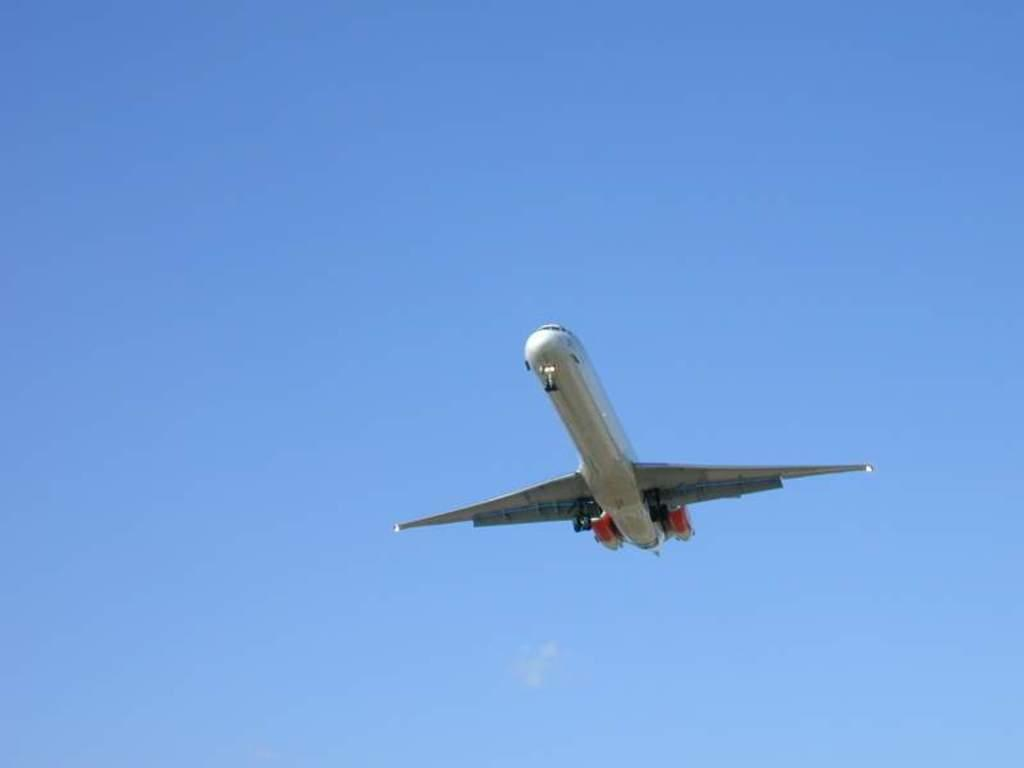What is the main subject of the image? The main subject of the image is an airplane. What is the airplane doing in the image? The airplane is flying in the air. What can be seen in the background of the image? There is a sky visible in the background of the image. What type of lipstick is the visitor wearing in the image? There is no visitor or lipstick present in the image; it features an airplane flying in the sky. 